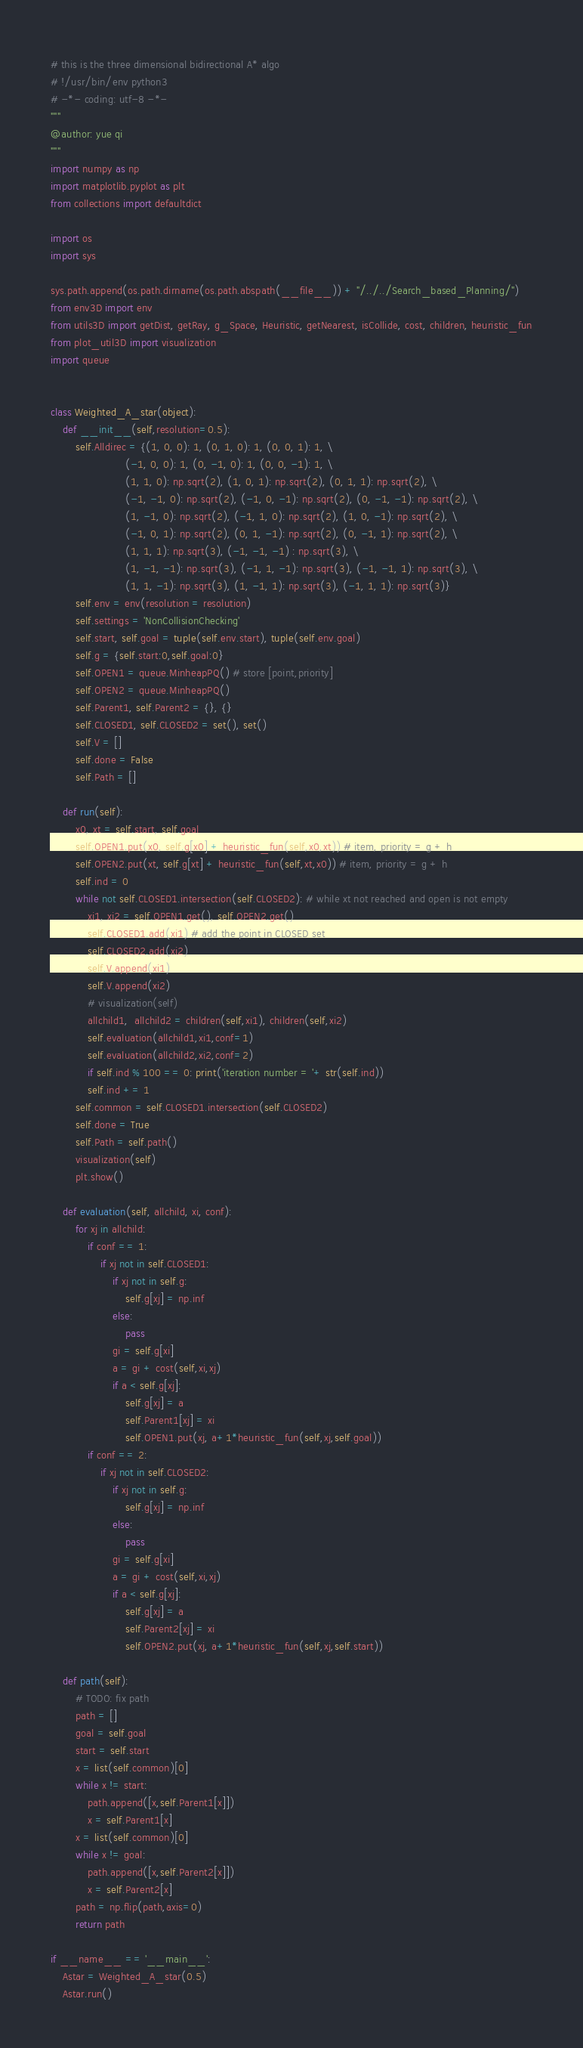Convert code to text. <code><loc_0><loc_0><loc_500><loc_500><_Python_># this is the three dimensional bidirectional A* algo
# !/usr/bin/env python3
# -*- coding: utf-8 -*-
"""
@author: yue qi
"""
import numpy as np
import matplotlib.pyplot as plt
from collections import defaultdict

import os
import sys

sys.path.append(os.path.dirname(os.path.abspath(__file__)) + "/../../Search_based_Planning/")
from env3D import env
from utils3D import getDist, getRay, g_Space, Heuristic, getNearest, isCollide, cost, children, heuristic_fun
from plot_util3D import visualization
import queue


class Weighted_A_star(object):
    def __init__(self,resolution=0.5):
        self.Alldirec = {(1, 0, 0): 1, (0, 1, 0): 1, (0, 0, 1): 1, \
                        (-1, 0, 0): 1, (0, -1, 0): 1, (0, 0, -1): 1, \
                        (1, 1, 0): np.sqrt(2), (1, 0, 1): np.sqrt(2), (0, 1, 1): np.sqrt(2), \
                        (-1, -1, 0): np.sqrt(2), (-1, 0, -1): np.sqrt(2), (0, -1, -1): np.sqrt(2), \
                        (1, -1, 0): np.sqrt(2), (-1, 1, 0): np.sqrt(2), (1, 0, -1): np.sqrt(2), \
                        (-1, 0, 1): np.sqrt(2), (0, 1, -1): np.sqrt(2), (0, -1, 1): np.sqrt(2), \
                        (1, 1, 1): np.sqrt(3), (-1, -1, -1) : np.sqrt(3), \
                        (1, -1, -1): np.sqrt(3), (-1, 1, -1): np.sqrt(3), (-1, -1, 1): np.sqrt(3), \
                        (1, 1, -1): np.sqrt(3), (1, -1, 1): np.sqrt(3), (-1, 1, 1): np.sqrt(3)}
        self.env = env(resolution = resolution)
        self.settings = 'NonCollisionChecking'
        self.start, self.goal = tuple(self.env.start), tuple(self.env.goal)
        self.g = {self.start:0,self.goal:0}
        self.OPEN1 = queue.MinheapPQ() # store [point,priority]
        self.OPEN2 = queue.MinheapPQ()
        self.Parent1, self.Parent2 = {}, {}
        self.CLOSED1, self.CLOSED2 = set(), set()
        self.V = []
        self.done = False
        self.Path = []

    def run(self):
        x0, xt = self.start, self.goal
        self.OPEN1.put(x0, self.g[x0] + heuristic_fun(self,x0,xt)) # item, priority = g + h
        self.OPEN2.put(xt, self.g[xt] + heuristic_fun(self,xt,x0)) # item, priority = g + h
        self.ind = 0
        while not self.CLOSED1.intersection(self.CLOSED2): # while xt not reached and open is not empty
            xi1, xi2 = self.OPEN1.get(), self.OPEN2.get() 
            self.CLOSED1.add(xi1) # add the point in CLOSED set
            self.CLOSED2.add(xi2)
            self.V.append(xi1)
            self.V.append(xi2)
            # visualization(self)
            allchild1,  allchild2 = children(self,xi1), children(self,xi2)
            self.evaluation(allchild1,xi1,conf=1)
            self.evaluation(allchild2,xi2,conf=2)
            if self.ind % 100 == 0: print('iteration number = '+ str(self.ind))
            self.ind += 1
        self.common = self.CLOSED1.intersection(self.CLOSED2)
        self.done = True
        self.Path = self.path()
        visualization(self)
        plt.show()

    def evaluation(self, allchild, xi, conf):
        for xj in allchild:
            if conf == 1:
                if xj not in self.CLOSED1:
                    if xj not in self.g:
                        self.g[xj] = np.inf
                    else:
                        pass
                    gi = self.g[xi]
                    a = gi + cost(self,xi,xj)
                    if a < self.g[xj]:
                        self.g[xj] = a
                        self.Parent1[xj] = xi
                        self.OPEN1.put(xj, a+1*heuristic_fun(self,xj,self.goal))
            if conf == 2:
                if xj not in self.CLOSED2:
                    if xj not in self.g:
                        self.g[xj] = np.inf
                    else:
                        pass
                    gi = self.g[xi]
                    a = gi + cost(self,xi,xj)
                    if a < self.g[xj]:
                        self.g[xj] = a
                        self.Parent2[xj] = xi
                        self.OPEN2.put(xj, a+1*heuristic_fun(self,xj,self.start))
            
    def path(self):
        # TODO: fix path
        path = []
        goal = self.goal
        start = self.start
        x = list(self.common)[0]
        while x != start:
            path.append([x,self.Parent1[x]])
            x = self.Parent1[x]
        x = list(self.common)[0]
        while x != goal:
            path.append([x,self.Parent2[x]])
            x = self.Parent2[x]
        path = np.flip(path,axis=0)
        return path

if __name__ == '__main__':
    Astar = Weighted_A_star(0.5)
    Astar.run()</code> 